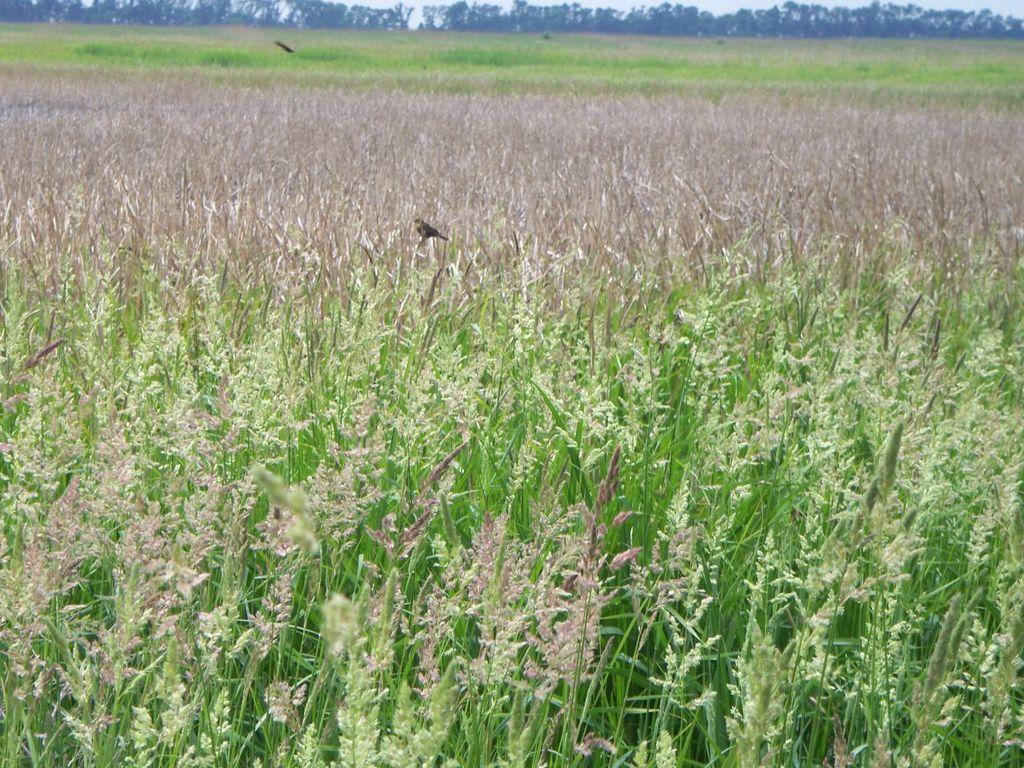How would you summarize this image in a sentence or two? This picture is taken from outside of the city. In this image, in the middle, we can see a bird standing on the plane. In the background, we can see some trees and a sky, at the bottom, we can see some plants and a grass. 